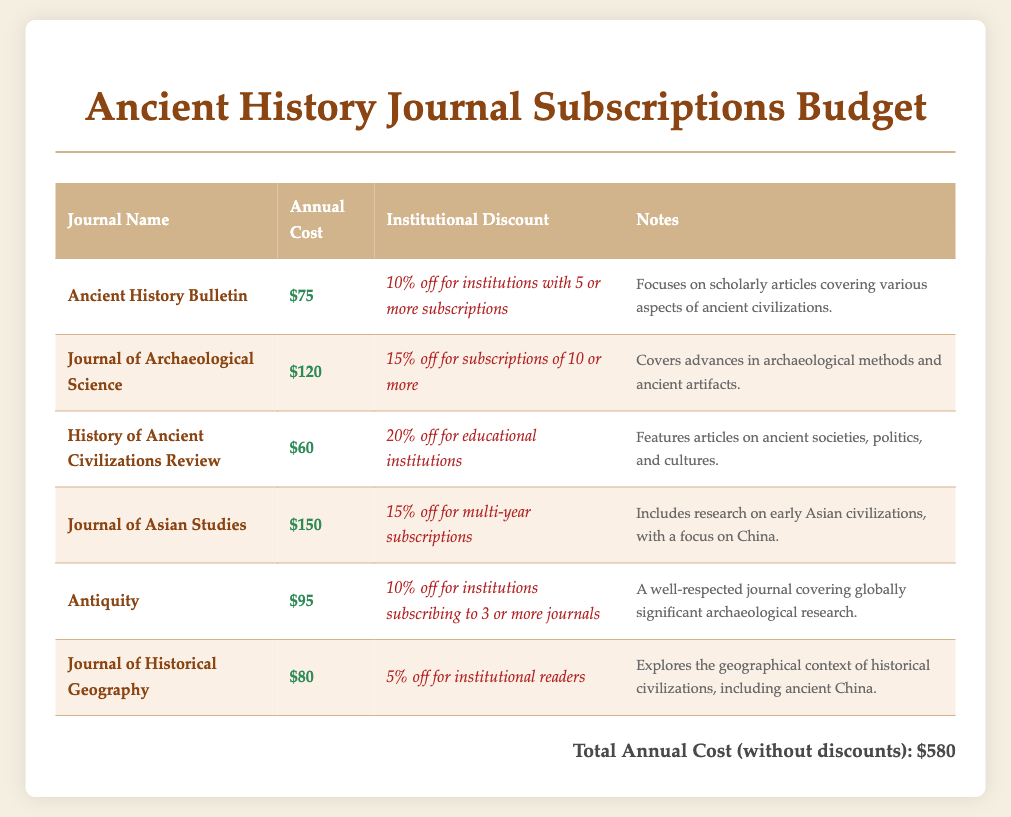What is the total annual cost without discounts? The total annual cost is explicitly stated in the document as $580.
Answer: $580 What is the annual cost of the Journal of Archaeological Science? The document lists the annual cost of this journal specifically as $120.
Answer: $120 Which journal offers a 20% discount for educational institutions? The History of Ancient Civilizations Review provides this discount, as noted in the document.
Answer: History of Ancient Civilizations Review What is the discount percentage for the Ancient History Bulletin if subscribed by an institution? The document states that it offers a 10% discount for institutions with 5 or more subscriptions.
Answer: 10% off Which journal focuses on early Asian civilizations? The Journal of Asian Studies is mentioned as covering this topic in the notes section of the document.
Answer: Journal of Asian Studies How many subscriptions are needed to get a 15% discount on the Journal of Archaeological Science? The document specifies that 10 or more subscriptions are required for this discount.
Answer: 10 What type of scholarly articles does Antiquity cover? The notes indicate that it covers globally significant archaeological research, as detailed in the document.
Answer: Globally significant archaeological research How much is the annual cost of the History of Ancient Civilizations Review? The document explicitly lists this cost as $60.
Answer: $60 What is the institutional discount for the Journal of Historical Geography? The document provides that there is a 5% discount for institutional readers.
Answer: 5% off 